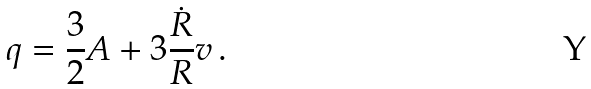<formula> <loc_0><loc_0><loc_500><loc_500>q = \frac { 3 } { 2 } A + 3 \frac { \dot { R } } { R } v \, .</formula> 